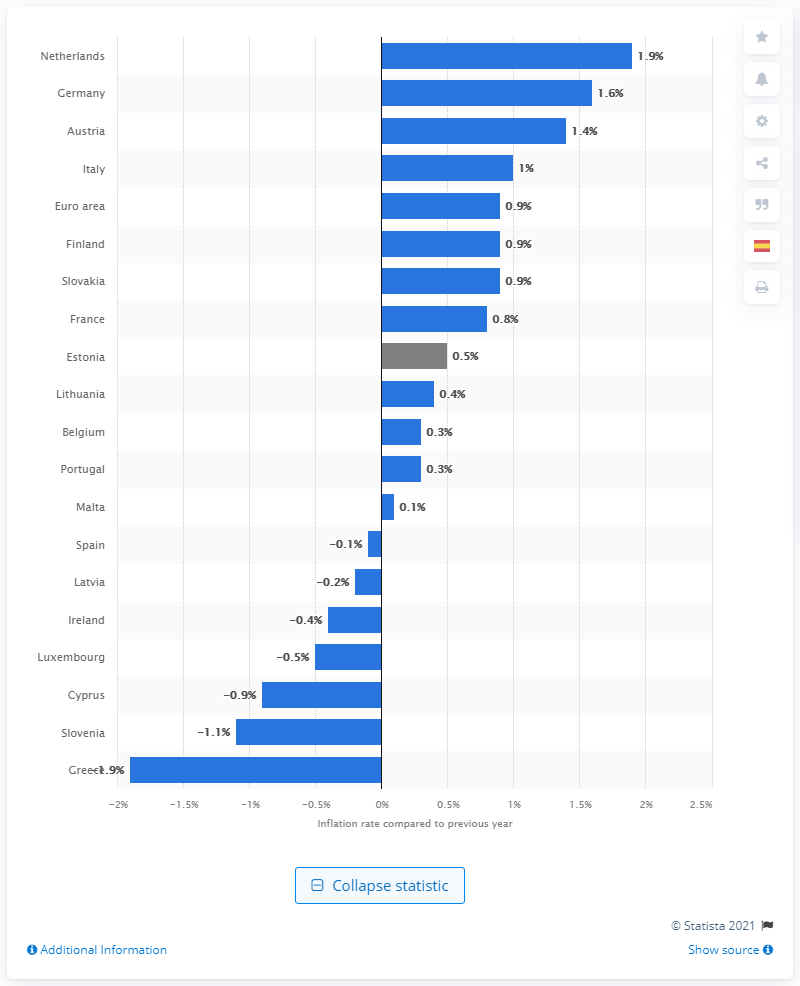Draw attention to some important aspects in this diagram. In February 2021, the inflation rate in Malta was 0.1%. 